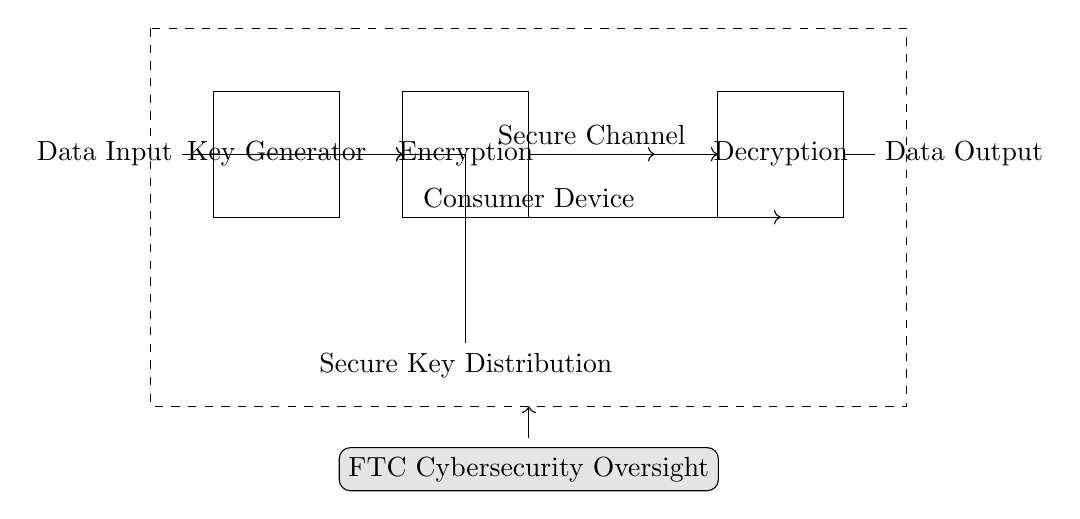What is the purpose of the key generator? The key generator is responsible for creating encryption keys that are essential for encrypting and decrypting data securely. Its role is critical in facilitating safe communication between sender and receiver in a circuit designed for asynchronous encryption.
Answer: Encryption keys What is the output of the decryption block? The decryption block processes the encrypted data transmitted through the secure channel and produces the original data as output. This block ensures that the recipient can access the data in its original form by reversing the encryption process.
Answer: Data Output How many main components are present in the circuit? The circuit includes four main components: Data Input, Key Generator, Encryption Block, and Decryption Block. These components work together to ensure secure data transmission and to handle the encryption process effectively.
Answer: Four What does the secure channel denote in this circuit? The secure channel indicates the transmitted path of encrypted data between the encryption block and decryption block, ensuring that the data remains confidential during transit. It implies that the data is protected against unauthorized access while being sent.
Answer: Secure Channel What is the function of secure key distribution? Secure key distribution is meant to allow safe sharing of encryption keys between the key generator and the decryption block. It ensures that only authorized devices can obtain these keys, thus maintaining the integrity of the encryption system.
Answer: Key sharing What type of encryption does this circuit implement? The circuit implements asynchronous encryption, which involves using a pair of keys: a public key for encryption and a private key for decryption. This differs from symmetric encryption where the same key is used for both processes.
Answer: Asynchronous encryption How does the FTC play a role in this circuit? The FTC is involved in oversight to ensure that cybersecurity laws are followed, which includes monitoring the implementation of secure data transmission practices within consumer devices. This regulatory role is pivotal in protecting consumer data and interests.
Answer: Cybersecurity Oversight 